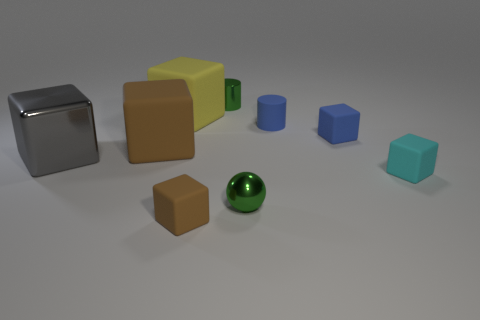Subtract all purple cylinders. How many brown blocks are left? 2 Subtract all large gray metallic blocks. How many blocks are left? 5 Subtract all yellow cubes. How many cubes are left? 5 Add 1 big yellow rubber things. How many objects exist? 10 Subtract 4 blocks. How many blocks are left? 2 Subtract all spheres. How many objects are left? 8 Subtract all purple cubes. Subtract all brown cylinders. How many cubes are left? 6 Add 1 gray blocks. How many gray blocks are left? 2 Add 6 large gray cylinders. How many large gray cylinders exist? 6 Subtract 0 purple cylinders. How many objects are left? 9 